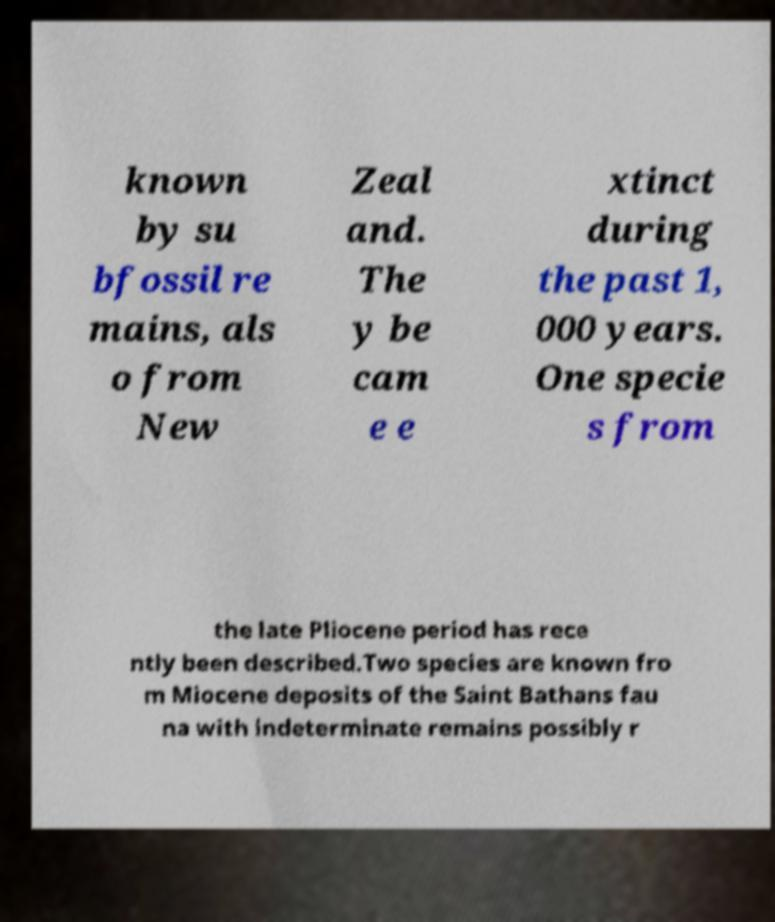Please identify and transcribe the text found in this image. known by su bfossil re mains, als o from New Zeal and. The y be cam e e xtinct during the past 1, 000 years. One specie s from the late Pliocene period has rece ntly been described.Two species are known fro m Miocene deposits of the Saint Bathans fau na with indeterminate remains possibly r 